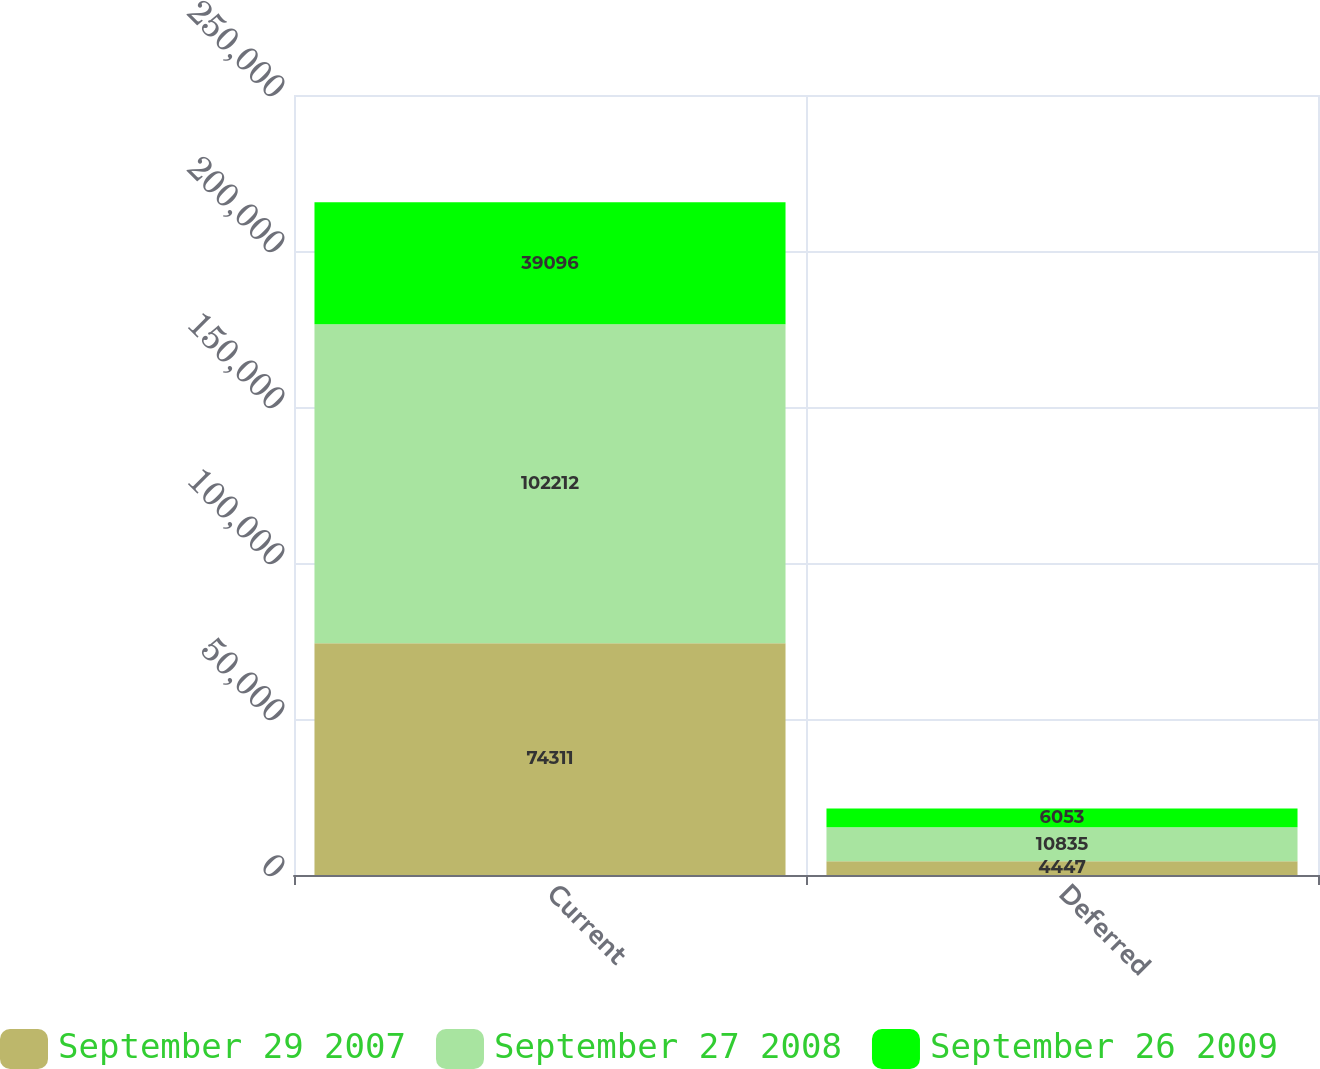Convert chart. <chart><loc_0><loc_0><loc_500><loc_500><stacked_bar_chart><ecel><fcel>Current<fcel>Deferred<nl><fcel>September 29 2007<fcel>74311<fcel>4447<nl><fcel>September 27 2008<fcel>102212<fcel>10835<nl><fcel>September 26 2009<fcel>39096<fcel>6053<nl></chart> 